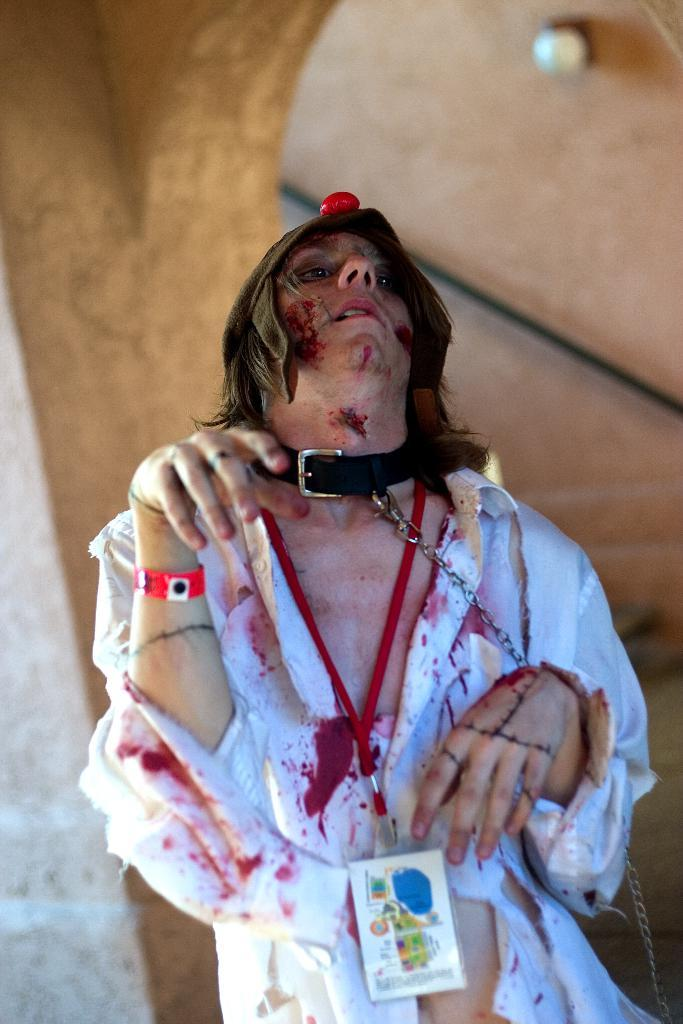What is the main subject of the image? There is a cosplay in the center of the image. What can be seen in the background of the image? There is a wall in the background of the image. What is the name of the cub that is playing with the cosplay in the image? There is no cub present in the image, and the cosplay is not interacting with any animals. 